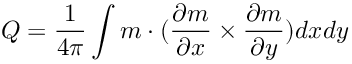Convert formula to latex. <formula><loc_0><loc_0><loc_500><loc_500>Q = \frac { 1 } { 4 \pi } \int m \cdot ( \frac { \partial m } { \partial x } \times \frac { \partial m } { \partial y } ) d x d y</formula> 